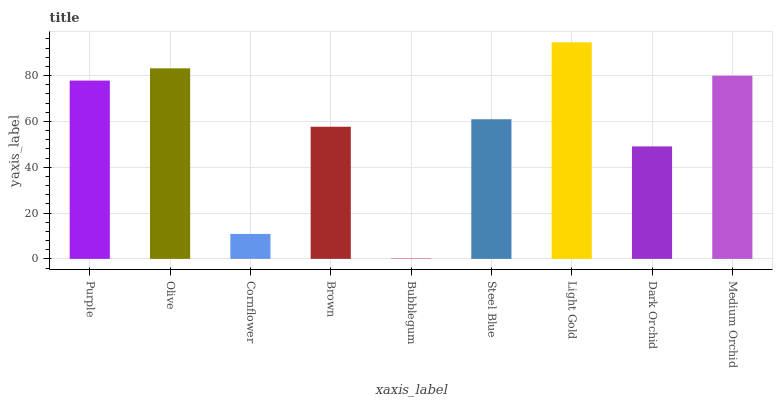Is Bubblegum the minimum?
Answer yes or no. Yes. Is Light Gold the maximum?
Answer yes or no. Yes. Is Olive the minimum?
Answer yes or no. No. Is Olive the maximum?
Answer yes or no. No. Is Olive greater than Purple?
Answer yes or no. Yes. Is Purple less than Olive?
Answer yes or no. Yes. Is Purple greater than Olive?
Answer yes or no. No. Is Olive less than Purple?
Answer yes or no. No. Is Steel Blue the high median?
Answer yes or no. Yes. Is Steel Blue the low median?
Answer yes or no. Yes. Is Bubblegum the high median?
Answer yes or no. No. Is Light Gold the low median?
Answer yes or no. No. 